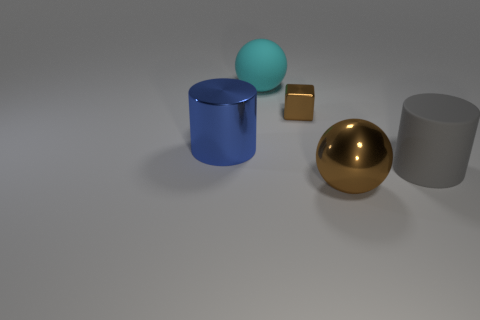Add 3 large things. How many objects exist? 8 Subtract all cyan cylinders. Subtract all red spheres. How many cylinders are left? 2 Subtract all purple cylinders. How many cyan balls are left? 1 Subtract all large shiny things. Subtract all big shiny balls. How many objects are left? 2 Add 5 brown metallic balls. How many brown metallic balls are left? 6 Add 5 brown metal spheres. How many brown metal spheres exist? 6 Subtract all cyan balls. How many balls are left? 1 Subtract 0 cyan blocks. How many objects are left? 5 Subtract all cylinders. How many objects are left? 3 Subtract 1 cubes. How many cubes are left? 0 